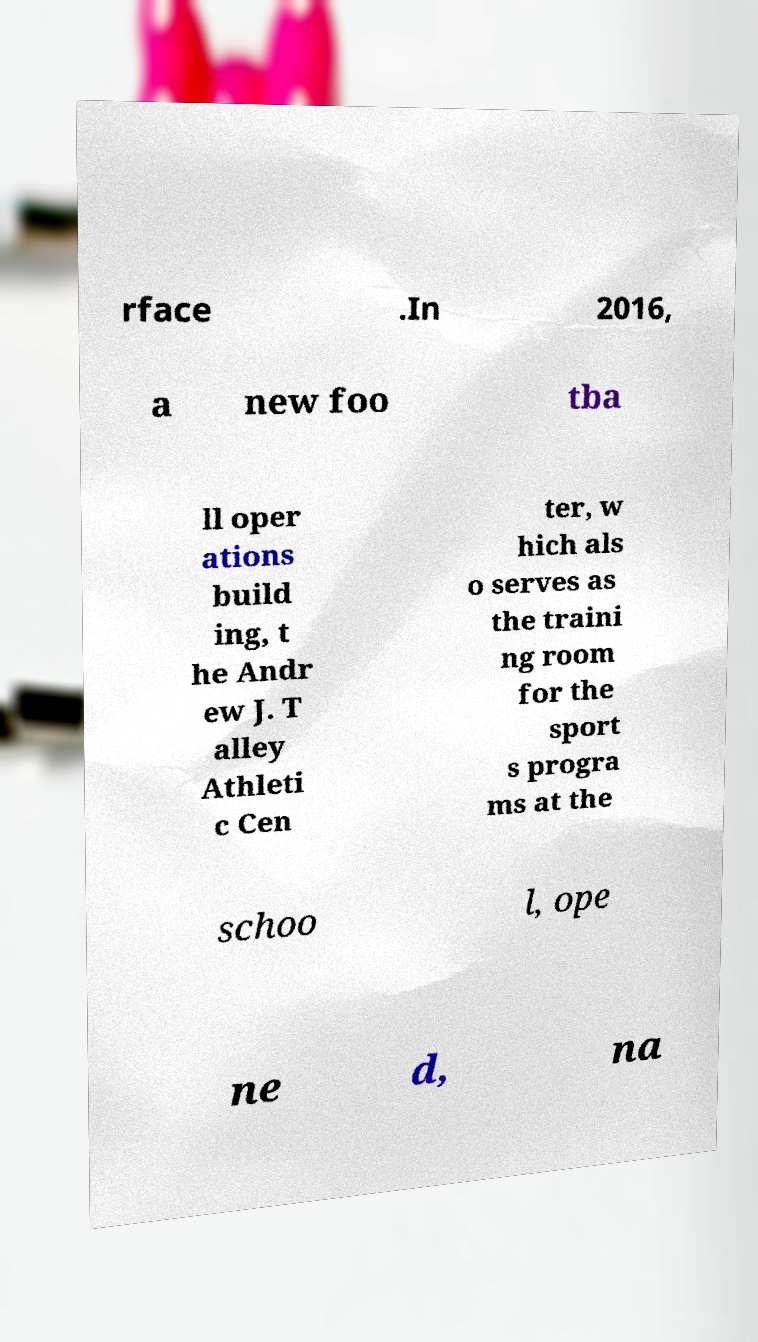Could you assist in decoding the text presented in this image and type it out clearly? rface .In 2016, a new foo tba ll oper ations build ing, t he Andr ew J. T alley Athleti c Cen ter, w hich als o serves as the traini ng room for the sport s progra ms at the schoo l, ope ne d, na 